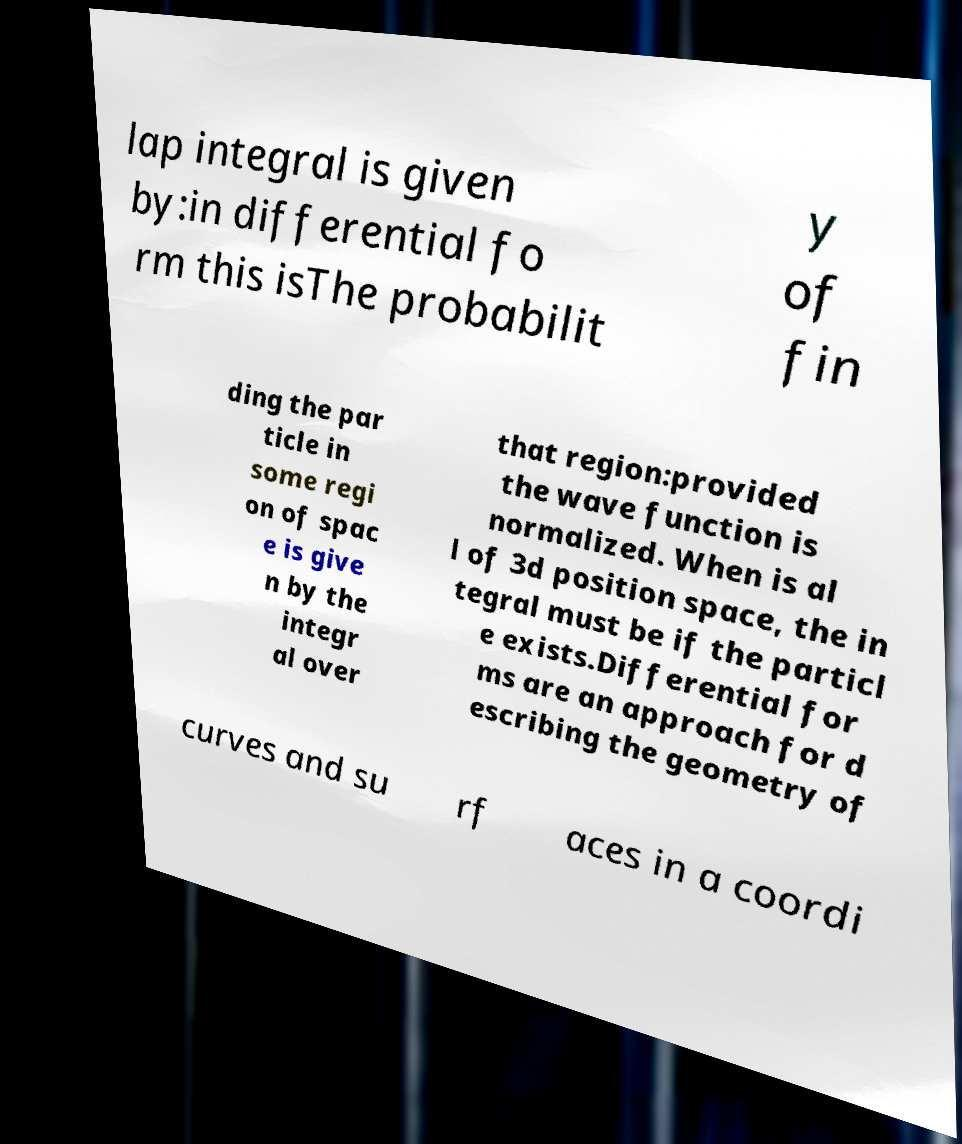Could you assist in decoding the text presented in this image and type it out clearly? lap integral is given by:in differential fo rm this isThe probabilit y of fin ding the par ticle in some regi on of spac e is give n by the integr al over that region:provided the wave function is normalized. When is al l of 3d position space, the in tegral must be if the particl e exists.Differential for ms are an approach for d escribing the geometry of curves and su rf aces in a coordi 